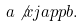Convert formula to latex. <formula><loc_0><loc_0><loc_500><loc_500>a \not x j a p p b .</formula> 